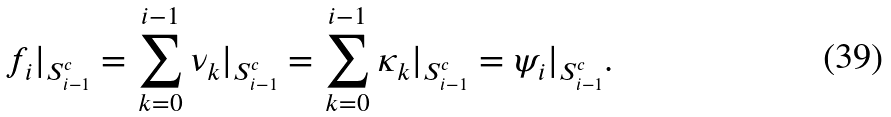Convert formula to latex. <formula><loc_0><loc_0><loc_500><loc_500>f _ { i } | _ { S _ { i - 1 } ^ { c } } = \sum _ { k = 0 } ^ { i - 1 } \nu _ { k } | _ { S _ { i - 1 } ^ { c } } = \sum _ { k = 0 } ^ { i - 1 } \kappa _ { k } | _ { S _ { i - 1 } ^ { c } } = \psi _ { i } | _ { S _ { i - 1 } ^ { c } } .</formula> 